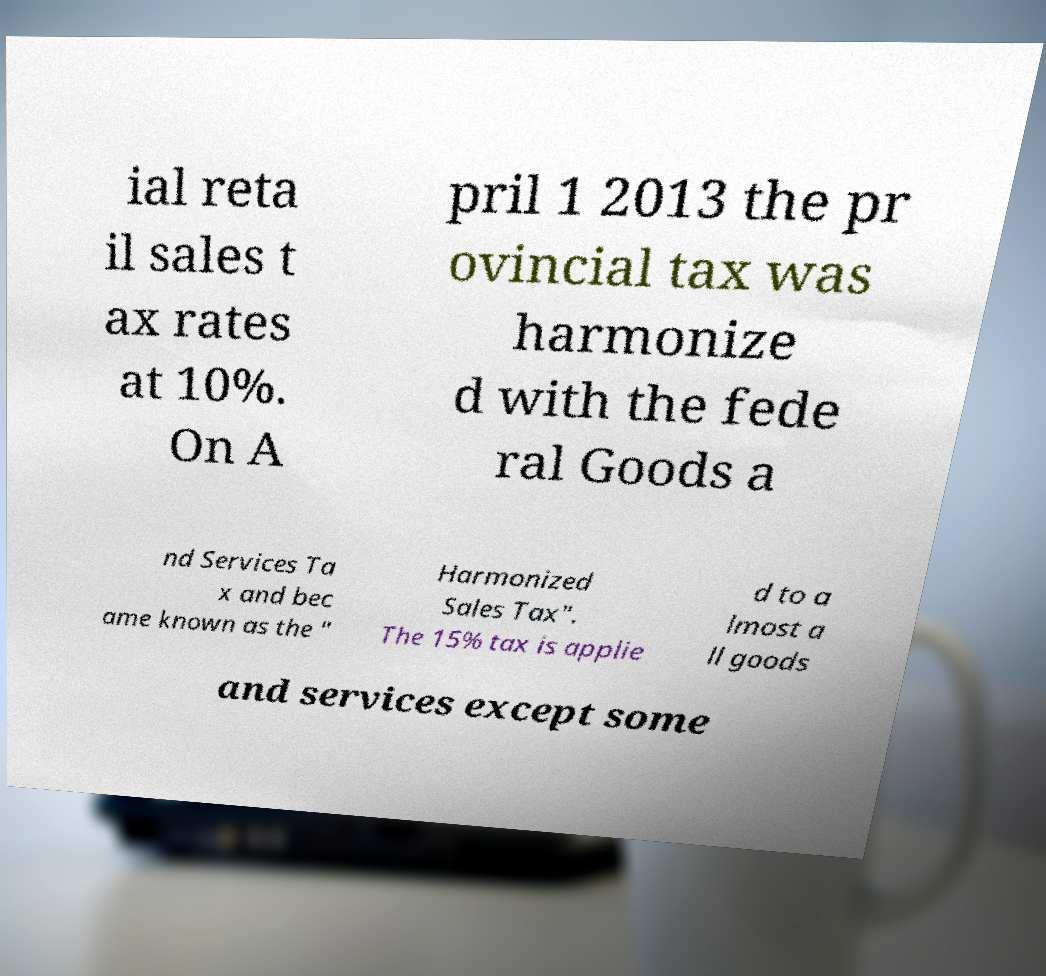Please read and relay the text visible in this image. What does it say? ial reta il sales t ax rates at 10%. On A pril 1 2013 the pr ovincial tax was harmonize d with the fede ral Goods a nd Services Ta x and bec ame known as the " Harmonized Sales Tax". The 15% tax is applie d to a lmost a ll goods and services except some 